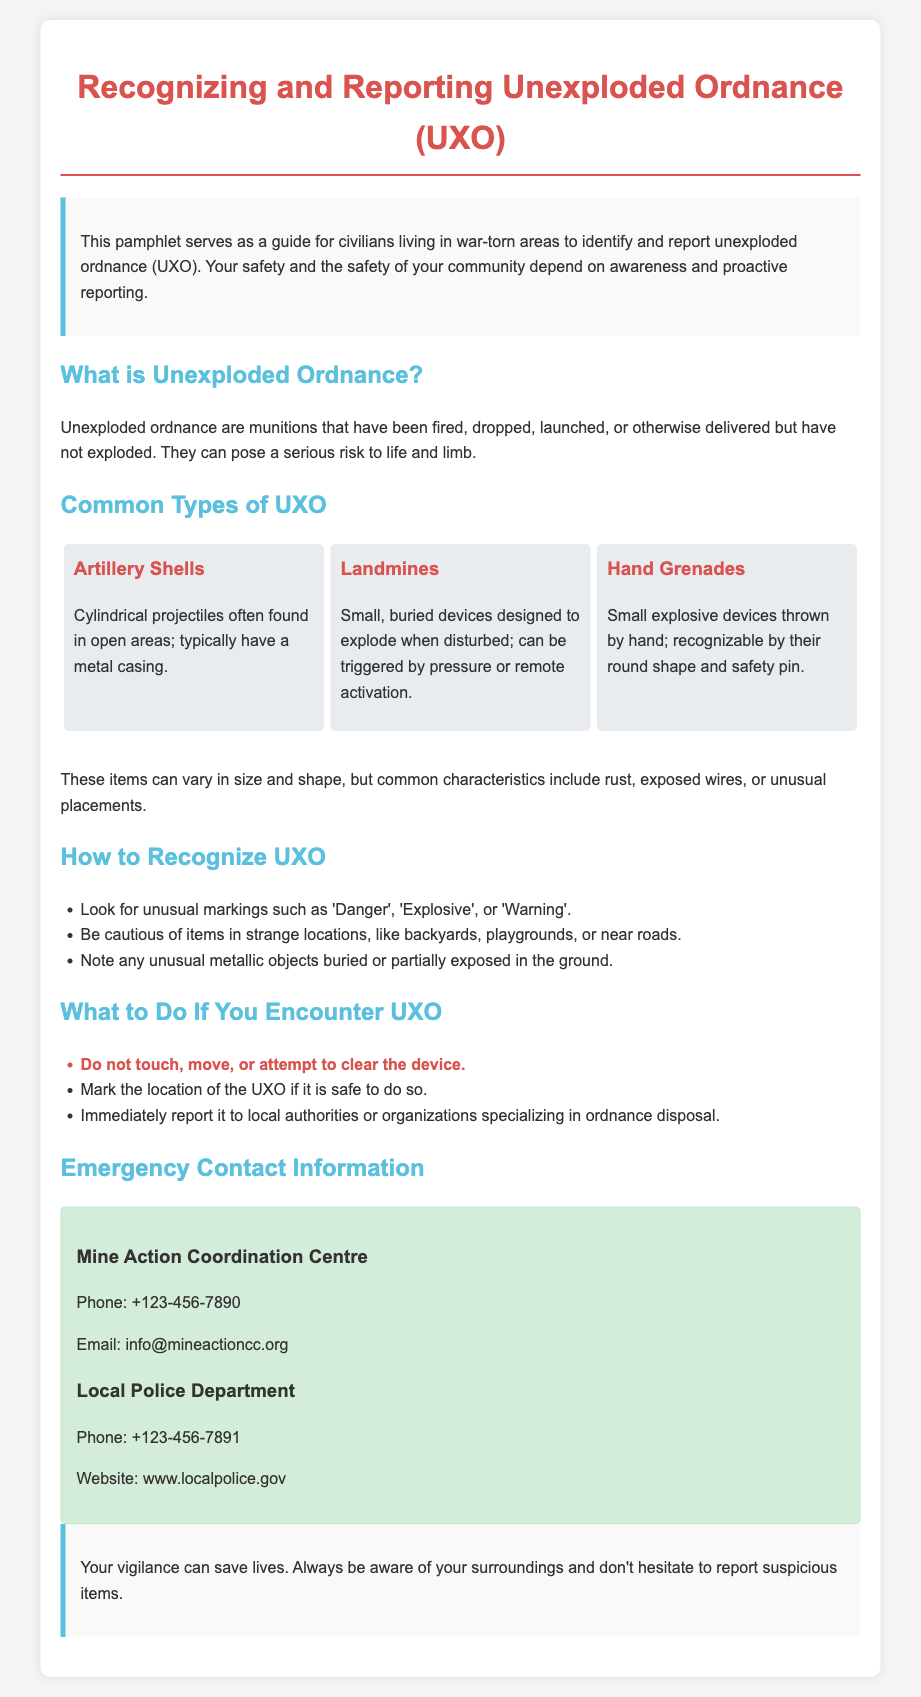What is the title of the pamphlet? The title is specified in the document's heading at the top.
Answer: Recognizing and Reporting Unexploded Ordnance (UXO) What are the common types of UXO listed in the document? The document lists three types of UXO in the common types section.
Answer: Artillery Shells, Landmines, Hand Grenades What should you not do when encountering UXO? The document includes a specific guideline about this in the "What to Do" section.
Answer: Do not touch, move, or attempt to clear the device Who should you report UXO to? The document mentions this in the instructions for what to do upon encountering UXO.
Answer: Local authorities or organizations specializing in ordnance disposal What is the phone number for the Mine Action Coordination Centre? The document provides contact information for this center.
Answer: +123-456-7890 What is a key characteristic of unexploded ordnance? The document emphasizes some common characteristics of UXO in the recognition section.
Answer: Rust, exposed wires, or unusual placements What color is used for the headings in the pamphlet? The document indicates the color used for headings in the styling section.
Answer: Red Why is reporting suspicious items important? The conclusion of the pamphlet highlights the significance of vigilance and reporting.
Answer: Save lives 